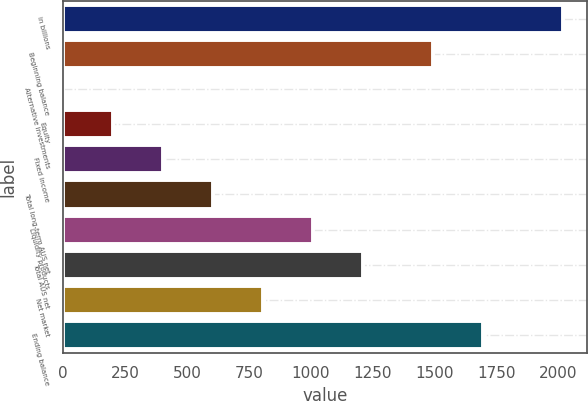Convert chart. <chart><loc_0><loc_0><loc_500><loc_500><bar_chart><fcel>in billions<fcel>Beginning balance<fcel>Alternative investments<fcel>Equity<fcel>Fixed income<fcel>Total long-term AUS net<fcel>Liquidity products<fcel>Total AUS net<fcel>Net market<fcel>Ending balance<nl><fcel>2018<fcel>1494<fcel>1<fcel>202.7<fcel>404.4<fcel>606.1<fcel>1009.5<fcel>1211.2<fcel>807.8<fcel>1695.7<nl></chart> 